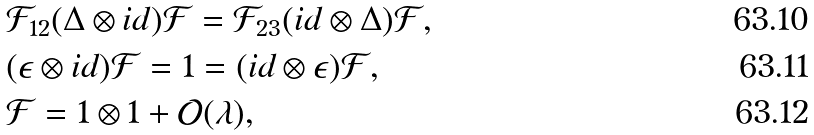<formula> <loc_0><loc_0><loc_500><loc_500>& \mathcal { F } _ { 1 2 } ( \Delta \otimes i d ) \mathcal { F } = \mathcal { F } _ { 2 3 } ( i d \otimes \Delta ) \mathcal { F } , \\ & ( \epsilon \otimes i d ) \mathcal { F } = 1 = ( i d \otimes \epsilon ) \mathcal { F } , \\ & \mathcal { F } = 1 \otimes 1 + \mathcal { O } ( \lambda ) ,</formula> 